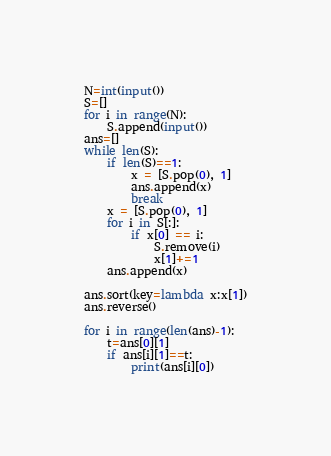<code> <loc_0><loc_0><loc_500><loc_500><_Python_>N=int(input())
S=[]
for i in range(N):
    S.append(input())
ans=[]
while len(S):
    if len(S)==1:
        x = [S.pop(0), 1]
        ans.append(x)
        break
    x = [S.pop(0), 1]
    for i in S[:]:
        if x[0] == i:
            S.remove(i)
            x[1]+=1
    ans.append(x)

ans.sort(key=lambda x:x[1])
ans.reverse()

for i in range(len(ans)-1):
    t=ans[0][1]
    if ans[i][1]==t:
        print(ans[i][0])
</code> 